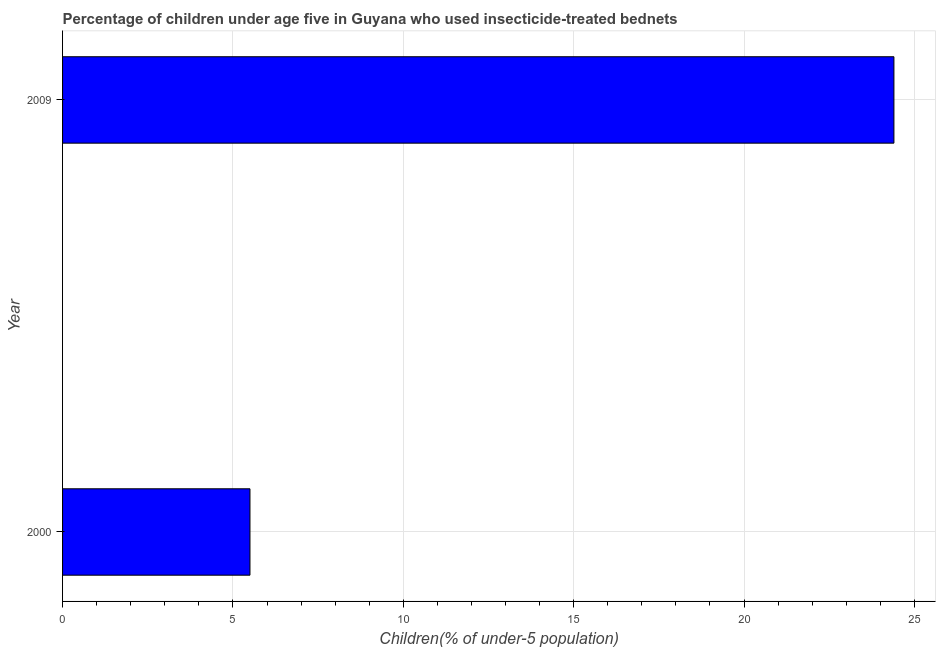Does the graph contain grids?
Make the answer very short. Yes. What is the title of the graph?
Offer a terse response. Percentage of children under age five in Guyana who used insecticide-treated bednets. What is the label or title of the X-axis?
Make the answer very short. Children(% of under-5 population). What is the label or title of the Y-axis?
Keep it short and to the point. Year. What is the percentage of children who use of insecticide-treated bed nets in 2009?
Provide a succinct answer. 24.4. Across all years, what is the maximum percentage of children who use of insecticide-treated bed nets?
Provide a short and direct response. 24.4. Across all years, what is the minimum percentage of children who use of insecticide-treated bed nets?
Offer a very short reply. 5.5. In which year was the percentage of children who use of insecticide-treated bed nets maximum?
Ensure brevity in your answer.  2009. What is the sum of the percentage of children who use of insecticide-treated bed nets?
Your answer should be very brief. 29.9. What is the difference between the percentage of children who use of insecticide-treated bed nets in 2000 and 2009?
Provide a succinct answer. -18.9. What is the average percentage of children who use of insecticide-treated bed nets per year?
Your answer should be very brief. 14.95. What is the median percentage of children who use of insecticide-treated bed nets?
Your response must be concise. 14.95. Do a majority of the years between 2000 and 2009 (inclusive) have percentage of children who use of insecticide-treated bed nets greater than 10 %?
Your answer should be very brief. No. What is the ratio of the percentage of children who use of insecticide-treated bed nets in 2000 to that in 2009?
Provide a short and direct response. 0.23. What is the difference between two consecutive major ticks on the X-axis?
Offer a terse response. 5. Are the values on the major ticks of X-axis written in scientific E-notation?
Give a very brief answer. No. What is the Children(% of under-5 population) in 2009?
Make the answer very short. 24.4. What is the difference between the Children(% of under-5 population) in 2000 and 2009?
Your response must be concise. -18.9. What is the ratio of the Children(% of under-5 population) in 2000 to that in 2009?
Provide a short and direct response. 0.23. 